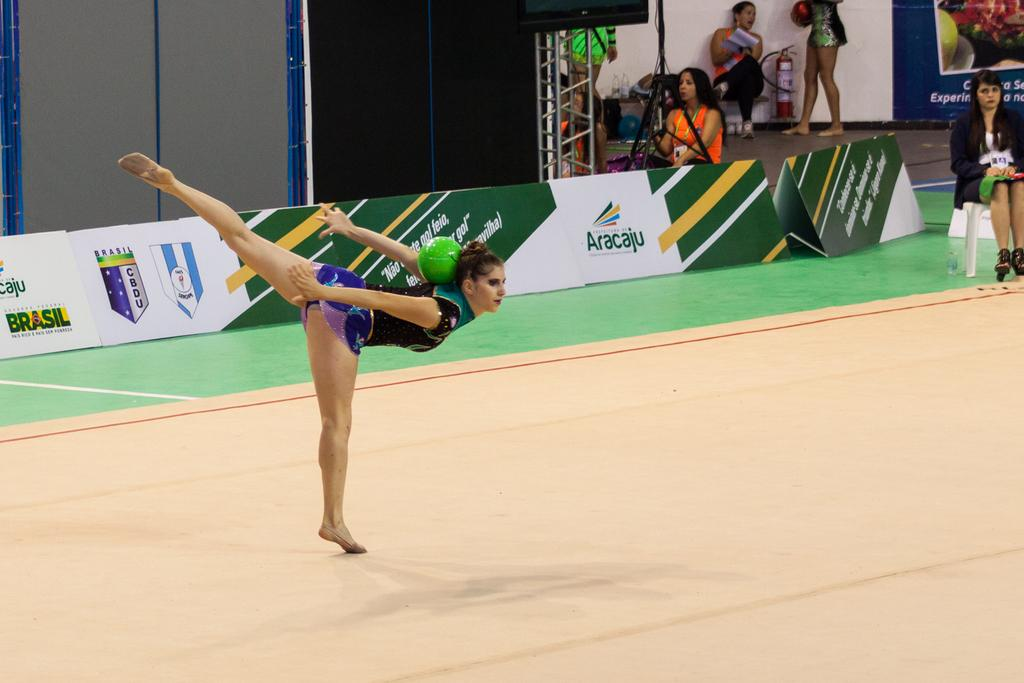<image>
Offer a succinct explanation of the picture presented. An Aracaju logo can be seen behind a girl doing gymnastics. 